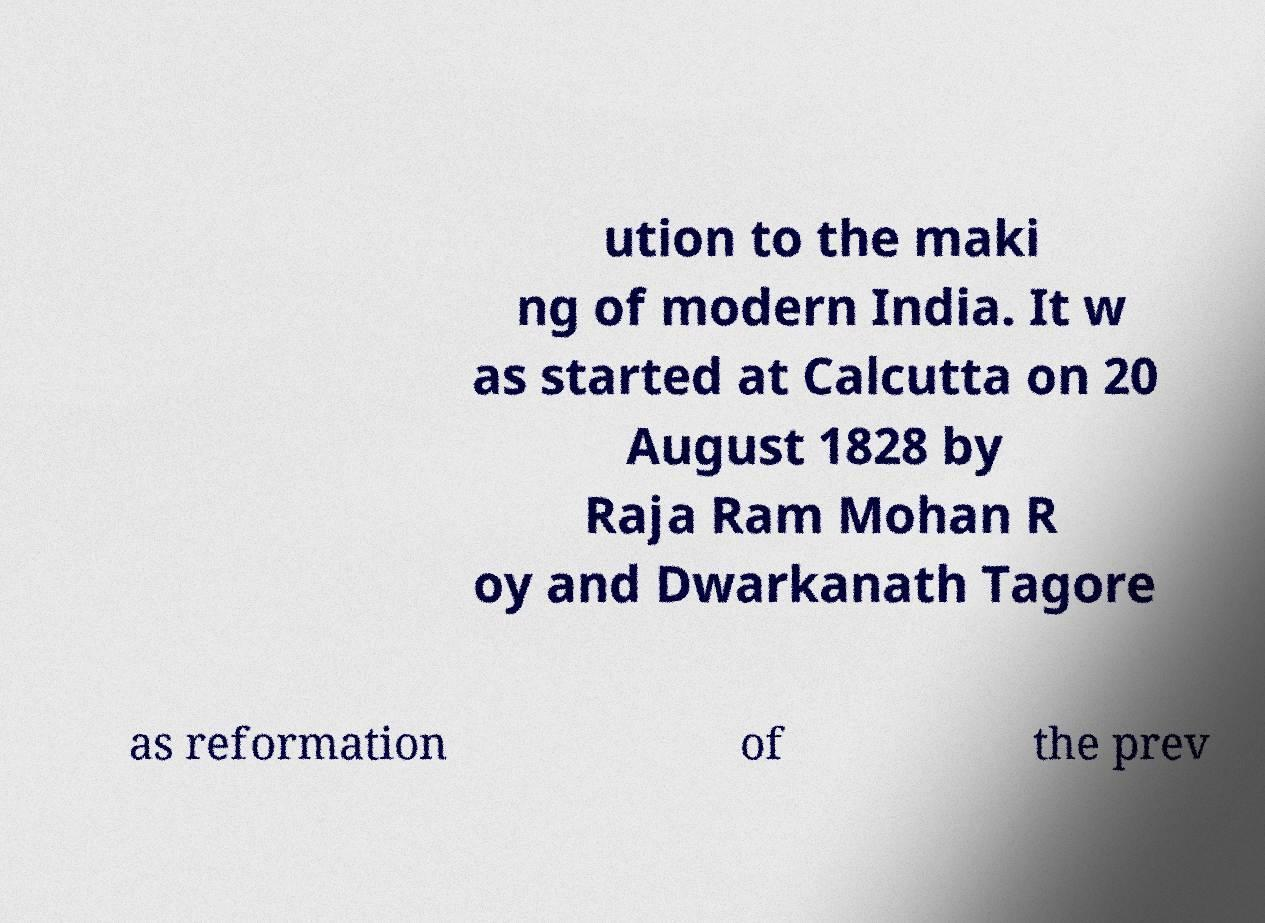For documentation purposes, I need the text within this image transcribed. Could you provide that? ution to the maki ng of modern India. It w as started at Calcutta on 20 August 1828 by Raja Ram Mohan R oy and Dwarkanath Tagore as reformation of the prev 